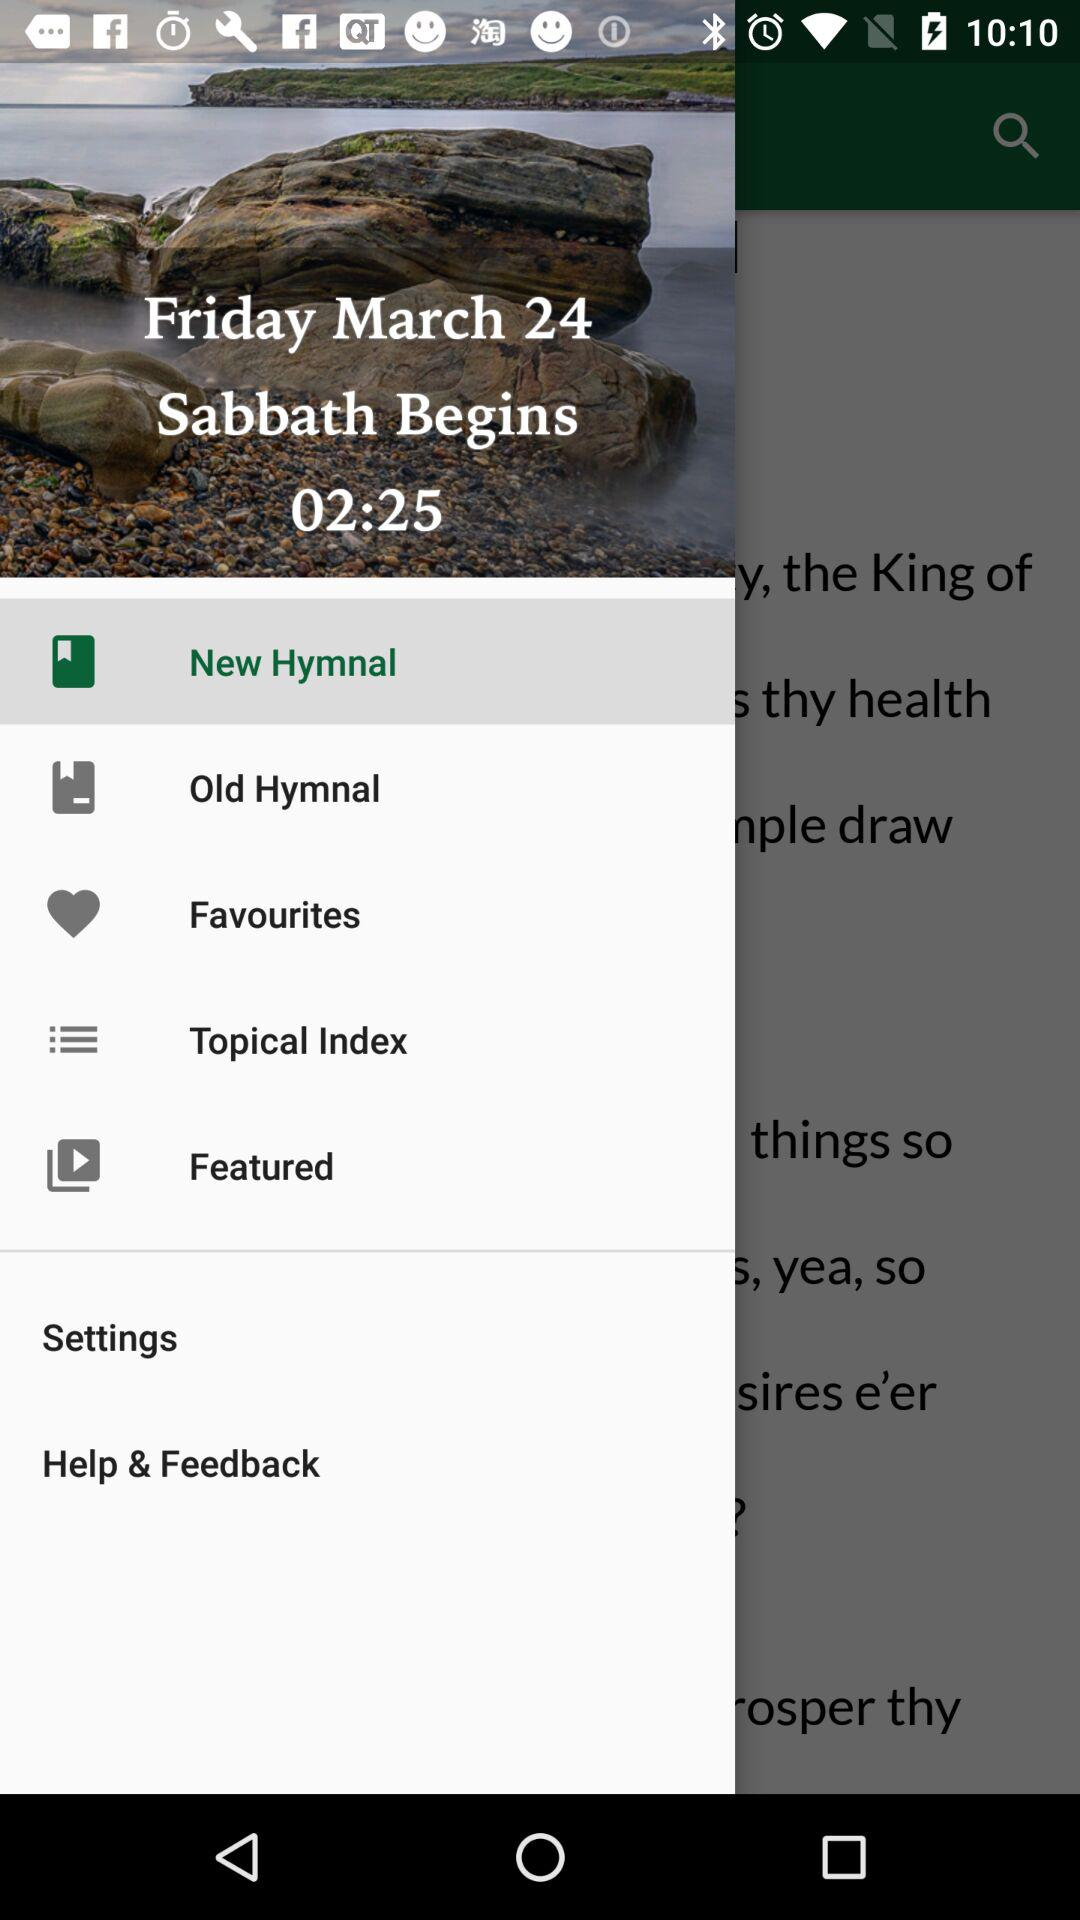What is the time at which the Sabbath begins? The sabbath begins at 02:25. 